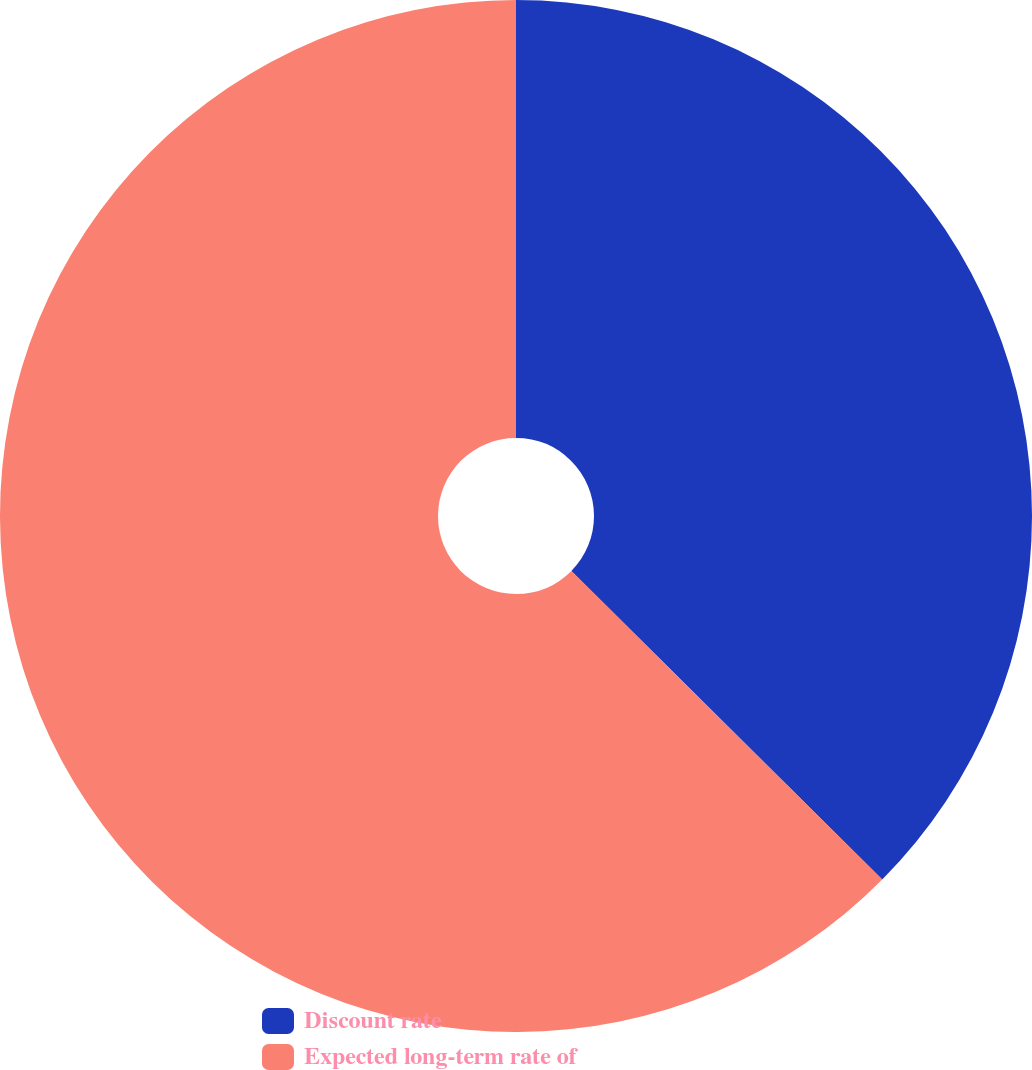<chart> <loc_0><loc_0><loc_500><loc_500><pie_chart><fcel>Discount rate<fcel>Expected long-term rate of<nl><fcel>37.44%<fcel>62.56%<nl></chart> 